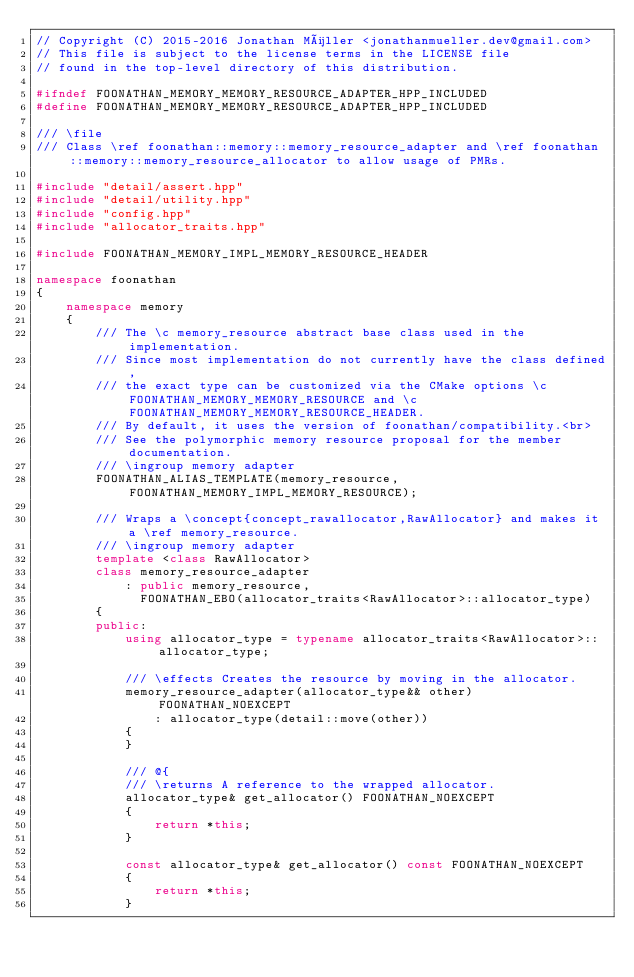<code> <loc_0><loc_0><loc_500><loc_500><_C++_>// Copyright (C) 2015-2016 Jonathan Müller <jonathanmueller.dev@gmail.com>
// This file is subject to the license terms in the LICENSE file
// found in the top-level directory of this distribution.

#ifndef FOONATHAN_MEMORY_MEMORY_RESOURCE_ADAPTER_HPP_INCLUDED
#define FOONATHAN_MEMORY_MEMORY_RESOURCE_ADAPTER_HPP_INCLUDED

/// \file
/// Class \ref foonathan::memory::memory_resource_adapter and \ref foonathan::memory::memory_resource_allocator to allow usage of PMRs.

#include "detail/assert.hpp"
#include "detail/utility.hpp"
#include "config.hpp"
#include "allocator_traits.hpp"

#include FOONATHAN_MEMORY_IMPL_MEMORY_RESOURCE_HEADER

namespace foonathan
{
    namespace memory
    {
        /// The \c memory_resource abstract base class used in the implementation.
        /// Since most implementation do not currently have the class defined,
        /// the exact type can be customized via the CMake options \c FOONATHAN_MEMORY_MEMORY_RESOURCE and \c FOONATHAN_MEMORY_MEMORY_RESOURCE_HEADER.
        /// By default, it uses the version of foonathan/compatibility.<br>
        /// See the polymorphic memory resource proposal for the member documentation.
        /// \ingroup memory adapter
        FOONATHAN_ALIAS_TEMPLATE(memory_resource, FOONATHAN_MEMORY_IMPL_MEMORY_RESOURCE);

        /// Wraps a \concept{concept_rawallocator,RawAllocator} and makes it a \ref memory_resource.
        /// \ingroup memory adapter
        template <class RawAllocator>
        class memory_resource_adapter
            : public memory_resource,
              FOONATHAN_EBO(allocator_traits<RawAllocator>::allocator_type)
        {
        public:
            using allocator_type = typename allocator_traits<RawAllocator>::allocator_type;

            /// \effects Creates the resource by moving in the allocator.
            memory_resource_adapter(allocator_type&& other) FOONATHAN_NOEXCEPT
                : allocator_type(detail::move(other))
            {
            }

            /// @{
            /// \returns A reference to the wrapped allocator.
            allocator_type& get_allocator() FOONATHAN_NOEXCEPT
            {
                return *this;
            }

            const allocator_type& get_allocator() const FOONATHAN_NOEXCEPT
            {
                return *this;
            }</code> 